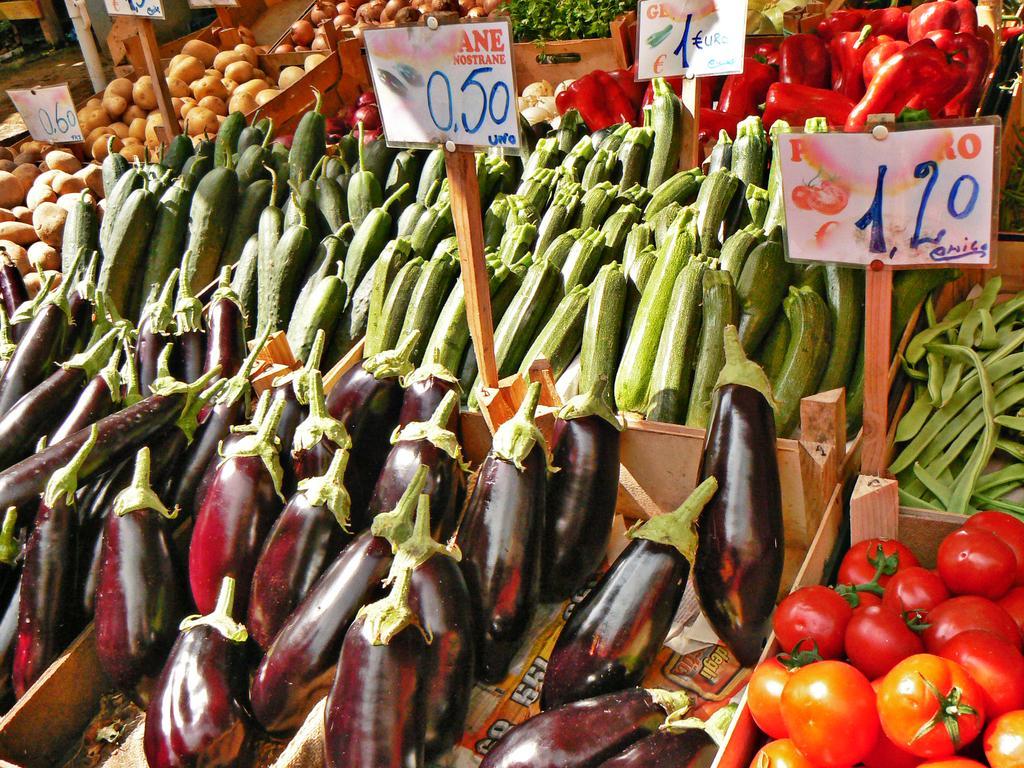Could you give a brief overview of what you see in this image? In this picture we can see some wooden baskets with some different type of vegetables, they are brinjal, tomato, potato, coriander, onion, and some other, on the wooden board there is a some text written on it. 